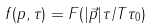<formula> <loc_0><loc_0><loc_500><loc_500>f ( p , \tau ) = F ( | { \vec { p } } | \tau / T \tau _ { 0 } )</formula> 